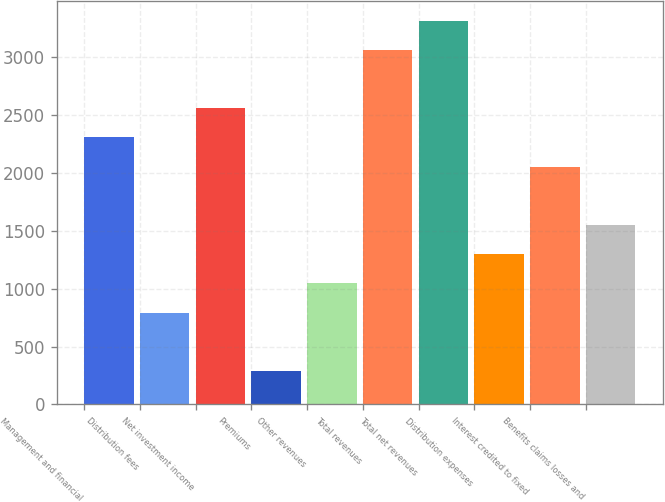<chart> <loc_0><loc_0><loc_500><loc_500><bar_chart><fcel>Management and financial<fcel>Distribution fees<fcel>Net investment income<fcel>Premiums<fcel>Other revenues<fcel>Total revenues<fcel>Total net revenues<fcel>Distribution expenses<fcel>Interest credited to fixed<fcel>Benefits claims losses and<nl><fcel>2308.6<fcel>794.2<fcel>2561<fcel>289.4<fcel>1046.6<fcel>3065.8<fcel>3318.2<fcel>1299<fcel>2056.2<fcel>1551.4<nl></chart> 